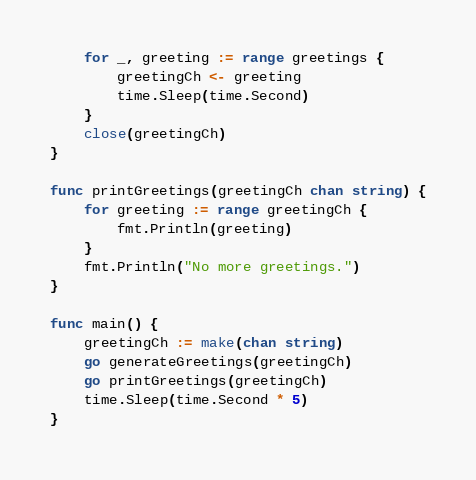<code> <loc_0><loc_0><loc_500><loc_500><_Go_>	for _, greeting := range greetings {
		greetingCh <- greeting
		time.Sleep(time.Second)
	}
	close(greetingCh)
}

func printGreetings(greetingCh chan string) {
	for greeting := range greetingCh {
		fmt.Println(greeting)
	}
	fmt.Println("No more greetings.")
}

func main() {
	greetingCh := make(chan string)
	go generateGreetings(greetingCh)
	go printGreetings(greetingCh)
	time.Sleep(time.Second * 5)
}
</code> 